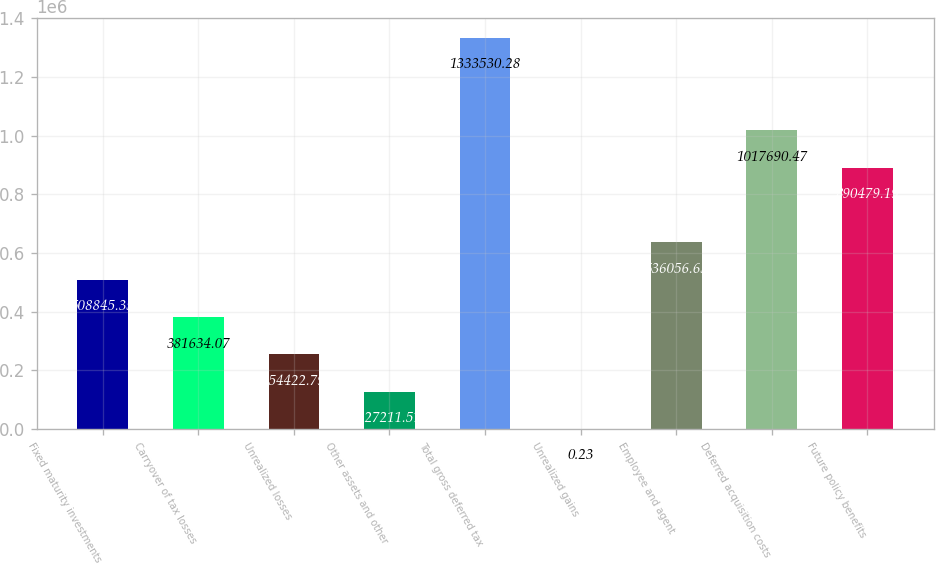<chart> <loc_0><loc_0><loc_500><loc_500><bar_chart><fcel>Fixed maturity investments<fcel>Carryover of tax losses<fcel>Unrealized losses<fcel>Other assets and other<fcel>Total gross deferred tax<fcel>Unrealized gains<fcel>Employee and agent<fcel>Deferred acquisition costs<fcel>Future policy benefits<nl><fcel>508845<fcel>381634<fcel>254423<fcel>127212<fcel>1.33353e+06<fcel>0.23<fcel>636057<fcel>1.01769e+06<fcel>890479<nl></chart> 